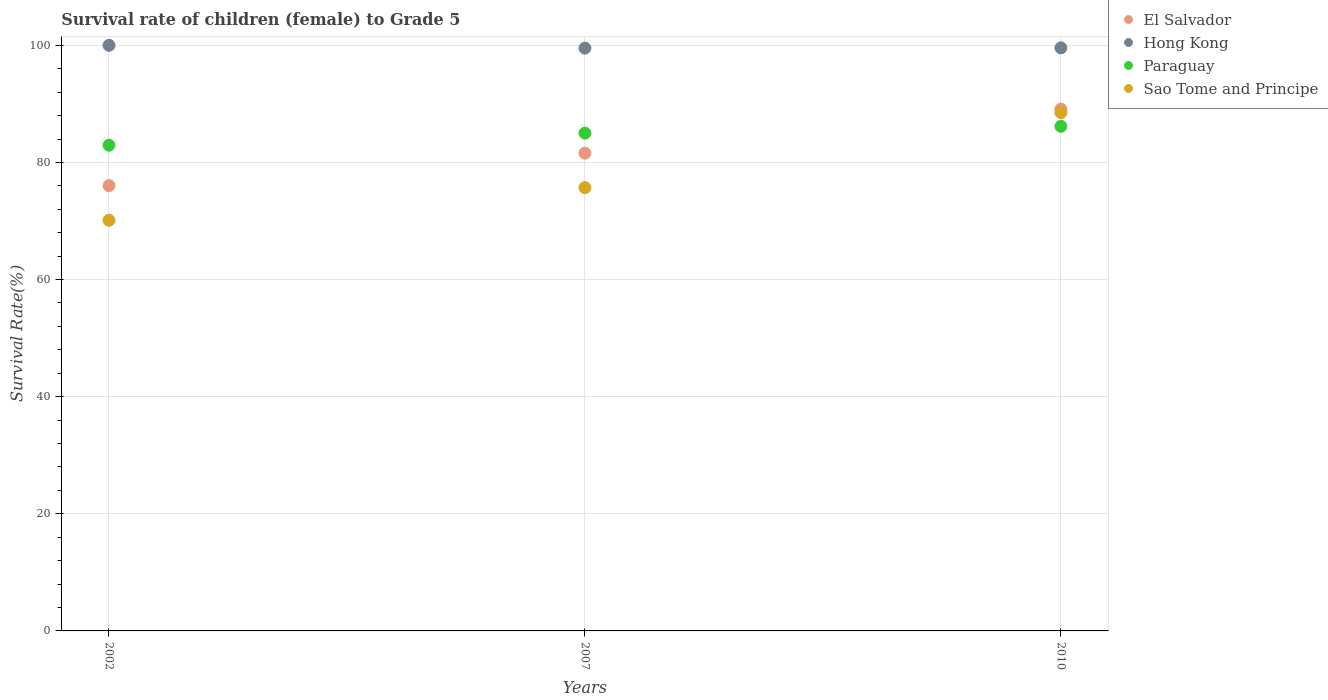How many different coloured dotlines are there?
Your response must be concise. 4. Is the number of dotlines equal to the number of legend labels?
Your response must be concise. Yes. What is the survival rate of female children to grade 5 in Paraguay in 2002?
Offer a terse response. 82.94. Across all years, what is the maximum survival rate of female children to grade 5 in Hong Kong?
Keep it short and to the point. 100. Across all years, what is the minimum survival rate of female children to grade 5 in Hong Kong?
Keep it short and to the point. 99.52. What is the total survival rate of female children to grade 5 in Paraguay in the graph?
Provide a short and direct response. 254.12. What is the difference between the survival rate of female children to grade 5 in El Salvador in 2002 and that in 2007?
Offer a terse response. -5.55. What is the difference between the survival rate of female children to grade 5 in Hong Kong in 2002 and the survival rate of female children to grade 5 in El Salvador in 2010?
Provide a succinct answer. 10.9. What is the average survival rate of female children to grade 5 in Paraguay per year?
Provide a succinct answer. 84.71. In the year 2002, what is the difference between the survival rate of female children to grade 5 in Hong Kong and survival rate of female children to grade 5 in El Salvador?
Offer a very short reply. 23.96. What is the ratio of the survival rate of female children to grade 5 in Sao Tome and Principe in 2002 to that in 2007?
Ensure brevity in your answer.  0.93. What is the difference between the highest and the second highest survival rate of female children to grade 5 in El Salvador?
Make the answer very short. 7.51. What is the difference between the highest and the lowest survival rate of female children to grade 5 in Hong Kong?
Keep it short and to the point. 0.48. In how many years, is the survival rate of female children to grade 5 in El Salvador greater than the average survival rate of female children to grade 5 in El Salvador taken over all years?
Give a very brief answer. 1. Is it the case that in every year, the sum of the survival rate of female children to grade 5 in Hong Kong and survival rate of female children to grade 5 in Sao Tome and Principe  is greater than the sum of survival rate of female children to grade 5 in Paraguay and survival rate of female children to grade 5 in El Salvador?
Your answer should be compact. Yes. Is it the case that in every year, the sum of the survival rate of female children to grade 5 in Hong Kong and survival rate of female children to grade 5 in Paraguay  is greater than the survival rate of female children to grade 5 in Sao Tome and Principe?
Provide a succinct answer. Yes. How many dotlines are there?
Offer a terse response. 4. How many years are there in the graph?
Your answer should be very brief. 3. Are the values on the major ticks of Y-axis written in scientific E-notation?
Make the answer very short. No. Does the graph contain grids?
Offer a very short reply. Yes. How many legend labels are there?
Provide a succinct answer. 4. What is the title of the graph?
Provide a short and direct response. Survival rate of children (female) to Grade 5. Does "Togo" appear as one of the legend labels in the graph?
Give a very brief answer. No. What is the label or title of the Y-axis?
Your answer should be very brief. Survival Rate(%). What is the Survival Rate(%) in El Salvador in 2002?
Ensure brevity in your answer.  76.04. What is the Survival Rate(%) of Paraguay in 2002?
Offer a very short reply. 82.94. What is the Survival Rate(%) in Sao Tome and Principe in 2002?
Provide a short and direct response. 70.12. What is the Survival Rate(%) in El Salvador in 2007?
Provide a short and direct response. 81.59. What is the Survival Rate(%) in Hong Kong in 2007?
Offer a very short reply. 99.52. What is the Survival Rate(%) of Paraguay in 2007?
Keep it short and to the point. 85.01. What is the Survival Rate(%) in Sao Tome and Principe in 2007?
Your answer should be compact. 75.69. What is the Survival Rate(%) of El Salvador in 2010?
Your answer should be very brief. 89.1. What is the Survival Rate(%) in Hong Kong in 2010?
Make the answer very short. 99.57. What is the Survival Rate(%) of Paraguay in 2010?
Give a very brief answer. 86.17. What is the Survival Rate(%) in Sao Tome and Principe in 2010?
Give a very brief answer. 88.52. Across all years, what is the maximum Survival Rate(%) in El Salvador?
Give a very brief answer. 89.1. Across all years, what is the maximum Survival Rate(%) of Paraguay?
Your response must be concise. 86.17. Across all years, what is the maximum Survival Rate(%) of Sao Tome and Principe?
Keep it short and to the point. 88.52. Across all years, what is the minimum Survival Rate(%) in El Salvador?
Keep it short and to the point. 76.04. Across all years, what is the minimum Survival Rate(%) of Hong Kong?
Provide a succinct answer. 99.52. Across all years, what is the minimum Survival Rate(%) of Paraguay?
Your response must be concise. 82.94. Across all years, what is the minimum Survival Rate(%) of Sao Tome and Principe?
Provide a succinct answer. 70.12. What is the total Survival Rate(%) of El Salvador in the graph?
Your answer should be compact. 246.72. What is the total Survival Rate(%) of Hong Kong in the graph?
Offer a very short reply. 299.09. What is the total Survival Rate(%) of Paraguay in the graph?
Your answer should be very brief. 254.12. What is the total Survival Rate(%) in Sao Tome and Principe in the graph?
Keep it short and to the point. 234.33. What is the difference between the Survival Rate(%) of El Salvador in 2002 and that in 2007?
Your response must be concise. -5.55. What is the difference between the Survival Rate(%) in Hong Kong in 2002 and that in 2007?
Make the answer very short. 0.48. What is the difference between the Survival Rate(%) of Paraguay in 2002 and that in 2007?
Give a very brief answer. -2.06. What is the difference between the Survival Rate(%) of Sao Tome and Principe in 2002 and that in 2007?
Offer a terse response. -5.57. What is the difference between the Survival Rate(%) in El Salvador in 2002 and that in 2010?
Keep it short and to the point. -13.06. What is the difference between the Survival Rate(%) of Hong Kong in 2002 and that in 2010?
Make the answer very short. 0.43. What is the difference between the Survival Rate(%) of Paraguay in 2002 and that in 2010?
Give a very brief answer. -3.23. What is the difference between the Survival Rate(%) in Sao Tome and Principe in 2002 and that in 2010?
Make the answer very short. -18.4. What is the difference between the Survival Rate(%) of El Salvador in 2007 and that in 2010?
Your answer should be compact. -7.51. What is the difference between the Survival Rate(%) in Hong Kong in 2007 and that in 2010?
Offer a terse response. -0.05. What is the difference between the Survival Rate(%) in Paraguay in 2007 and that in 2010?
Provide a short and direct response. -1.16. What is the difference between the Survival Rate(%) in Sao Tome and Principe in 2007 and that in 2010?
Give a very brief answer. -12.82. What is the difference between the Survival Rate(%) in El Salvador in 2002 and the Survival Rate(%) in Hong Kong in 2007?
Ensure brevity in your answer.  -23.49. What is the difference between the Survival Rate(%) in El Salvador in 2002 and the Survival Rate(%) in Paraguay in 2007?
Offer a terse response. -8.97. What is the difference between the Survival Rate(%) in El Salvador in 2002 and the Survival Rate(%) in Sao Tome and Principe in 2007?
Offer a very short reply. 0.34. What is the difference between the Survival Rate(%) in Hong Kong in 2002 and the Survival Rate(%) in Paraguay in 2007?
Offer a terse response. 14.99. What is the difference between the Survival Rate(%) in Hong Kong in 2002 and the Survival Rate(%) in Sao Tome and Principe in 2007?
Provide a succinct answer. 24.31. What is the difference between the Survival Rate(%) of Paraguay in 2002 and the Survival Rate(%) of Sao Tome and Principe in 2007?
Ensure brevity in your answer.  7.25. What is the difference between the Survival Rate(%) of El Salvador in 2002 and the Survival Rate(%) of Hong Kong in 2010?
Your answer should be compact. -23.53. What is the difference between the Survival Rate(%) of El Salvador in 2002 and the Survival Rate(%) of Paraguay in 2010?
Give a very brief answer. -10.13. What is the difference between the Survival Rate(%) of El Salvador in 2002 and the Survival Rate(%) of Sao Tome and Principe in 2010?
Your answer should be very brief. -12.48. What is the difference between the Survival Rate(%) of Hong Kong in 2002 and the Survival Rate(%) of Paraguay in 2010?
Your answer should be compact. 13.83. What is the difference between the Survival Rate(%) of Hong Kong in 2002 and the Survival Rate(%) of Sao Tome and Principe in 2010?
Offer a terse response. 11.48. What is the difference between the Survival Rate(%) in Paraguay in 2002 and the Survival Rate(%) in Sao Tome and Principe in 2010?
Give a very brief answer. -5.58. What is the difference between the Survival Rate(%) in El Salvador in 2007 and the Survival Rate(%) in Hong Kong in 2010?
Offer a very short reply. -17.98. What is the difference between the Survival Rate(%) of El Salvador in 2007 and the Survival Rate(%) of Paraguay in 2010?
Your answer should be very brief. -4.58. What is the difference between the Survival Rate(%) in El Salvador in 2007 and the Survival Rate(%) in Sao Tome and Principe in 2010?
Make the answer very short. -6.93. What is the difference between the Survival Rate(%) of Hong Kong in 2007 and the Survival Rate(%) of Paraguay in 2010?
Your answer should be very brief. 13.35. What is the difference between the Survival Rate(%) of Hong Kong in 2007 and the Survival Rate(%) of Sao Tome and Principe in 2010?
Your answer should be very brief. 11. What is the difference between the Survival Rate(%) in Paraguay in 2007 and the Survival Rate(%) in Sao Tome and Principe in 2010?
Offer a very short reply. -3.51. What is the average Survival Rate(%) of El Salvador per year?
Offer a terse response. 82.24. What is the average Survival Rate(%) in Hong Kong per year?
Your answer should be very brief. 99.7. What is the average Survival Rate(%) of Paraguay per year?
Your response must be concise. 84.71. What is the average Survival Rate(%) in Sao Tome and Principe per year?
Your answer should be compact. 78.11. In the year 2002, what is the difference between the Survival Rate(%) of El Salvador and Survival Rate(%) of Hong Kong?
Give a very brief answer. -23.96. In the year 2002, what is the difference between the Survival Rate(%) in El Salvador and Survival Rate(%) in Paraguay?
Your response must be concise. -6.91. In the year 2002, what is the difference between the Survival Rate(%) in El Salvador and Survival Rate(%) in Sao Tome and Principe?
Provide a succinct answer. 5.92. In the year 2002, what is the difference between the Survival Rate(%) of Hong Kong and Survival Rate(%) of Paraguay?
Offer a terse response. 17.06. In the year 2002, what is the difference between the Survival Rate(%) of Hong Kong and Survival Rate(%) of Sao Tome and Principe?
Keep it short and to the point. 29.88. In the year 2002, what is the difference between the Survival Rate(%) of Paraguay and Survival Rate(%) of Sao Tome and Principe?
Give a very brief answer. 12.82. In the year 2007, what is the difference between the Survival Rate(%) of El Salvador and Survival Rate(%) of Hong Kong?
Give a very brief answer. -17.94. In the year 2007, what is the difference between the Survival Rate(%) of El Salvador and Survival Rate(%) of Paraguay?
Offer a terse response. -3.42. In the year 2007, what is the difference between the Survival Rate(%) in El Salvador and Survival Rate(%) in Sao Tome and Principe?
Offer a terse response. 5.89. In the year 2007, what is the difference between the Survival Rate(%) in Hong Kong and Survival Rate(%) in Paraguay?
Keep it short and to the point. 14.52. In the year 2007, what is the difference between the Survival Rate(%) in Hong Kong and Survival Rate(%) in Sao Tome and Principe?
Offer a very short reply. 23.83. In the year 2007, what is the difference between the Survival Rate(%) of Paraguay and Survival Rate(%) of Sao Tome and Principe?
Give a very brief answer. 9.31. In the year 2010, what is the difference between the Survival Rate(%) in El Salvador and Survival Rate(%) in Hong Kong?
Your answer should be very brief. -10.47. In the year 2010, what is the difference between the Survival Rate(%) in El Salvador and Survival Rate(%) in Paraguay?
Offer a terse response. 2.93. In the year 2010, what is the difference between the Survival Rate(%) in El Salvador and Survival Rate(%) in Sao Tome and Principe?
Keep it short and to the point. 0.58. In the year 2010, what is the difference between the Survival Rate(%) in Hong Kong and Survival Rate(%) in Paraguay?
Your response must be concise. 13.4. In the year 2010, what is the difference between the Survival Rate(%) of Hong Kong and Survival Rate(%) of Sao Tome and Principe?
Offer a very short reply. 11.05. In the year 2010, what is the difference between the Survival Rate(%) in Paraguay and Survival Rate(%) in Sao Tome and Principe?
Ensure brevity in your answer.  -2.35. What is the ratio of the Survival Rate(%) in El Salvador in 2002 to that in 2007?
Offer a very short reply. 0.93. What is the ratio of the Survival Rate(%) in Paraguay in 2002 to that in 2007?
Provide a succinct answer. 0.98. What is the ratio of the Survival Rate(%) in Sao Tome and Principe in 2002 to that in 2007?
Give a very brief answer. 0.93. What is the ratio of the Survival Rate(%) in El Salvador in 2002 to that in 2010?
Your answer should be very brief. 0.85. What is the ratio of the Survival Rate(%) in Paraguay in 2002 to that in 2010?
Ensure brevity in your answer.  0.96. What is the ratio of the Survival Rate(%) of Sao Tome and Principe in 2002 to that in 2010?
Provide a short and direct response. 0.79. What is the ratio of the Survival Rate(%) in El Salvador in 2007 to that in 2010?
Make the answer very short. 0.92. What is the ratio of the Survival Rate(%) in Paraguay in 2007 to that in 2010?
Your response must be concise. 0.99. What is the ratio of the Survival Rate(%) in Sao Tome and Principe in 2007 to that in 2010?
Make the answer very short. 0.86. What is the difference between the highest and the second highest Survival Rate(%) of El Salvador?
Give a very brief answer. 7.51. What is the difference between the highest and the second highest Survival Rate(%) in Hong Kong?
Ensure brevity in your answer.  0.43. What is the difference between the highest and the second highest Survival Rate(%) of Paraguay?
Keep it short and to the point. 1.16. What is the difference between the highest and the second highest Survival Rate(%) of Sao Tome and Principe?
Provide a short and direct response. 12.82. What is the difference between the highest and the lowest Survival Rate(%) of El Salvador?
Your answer should be compact. 13.06. What is the difference between the highest and the lowest Survival Rate(%) in Hong Kong?
Ensure brevity in your answer.  0.48. What is the difference between the highest and the lowest Survival Rate(%) in Paraguay?
Offer a terse response. 3.23. What is the difference between the highest and the lowest Survival Rate(%) in Sao Tome and Principe?
Provide a succinct answer. 18.4. 